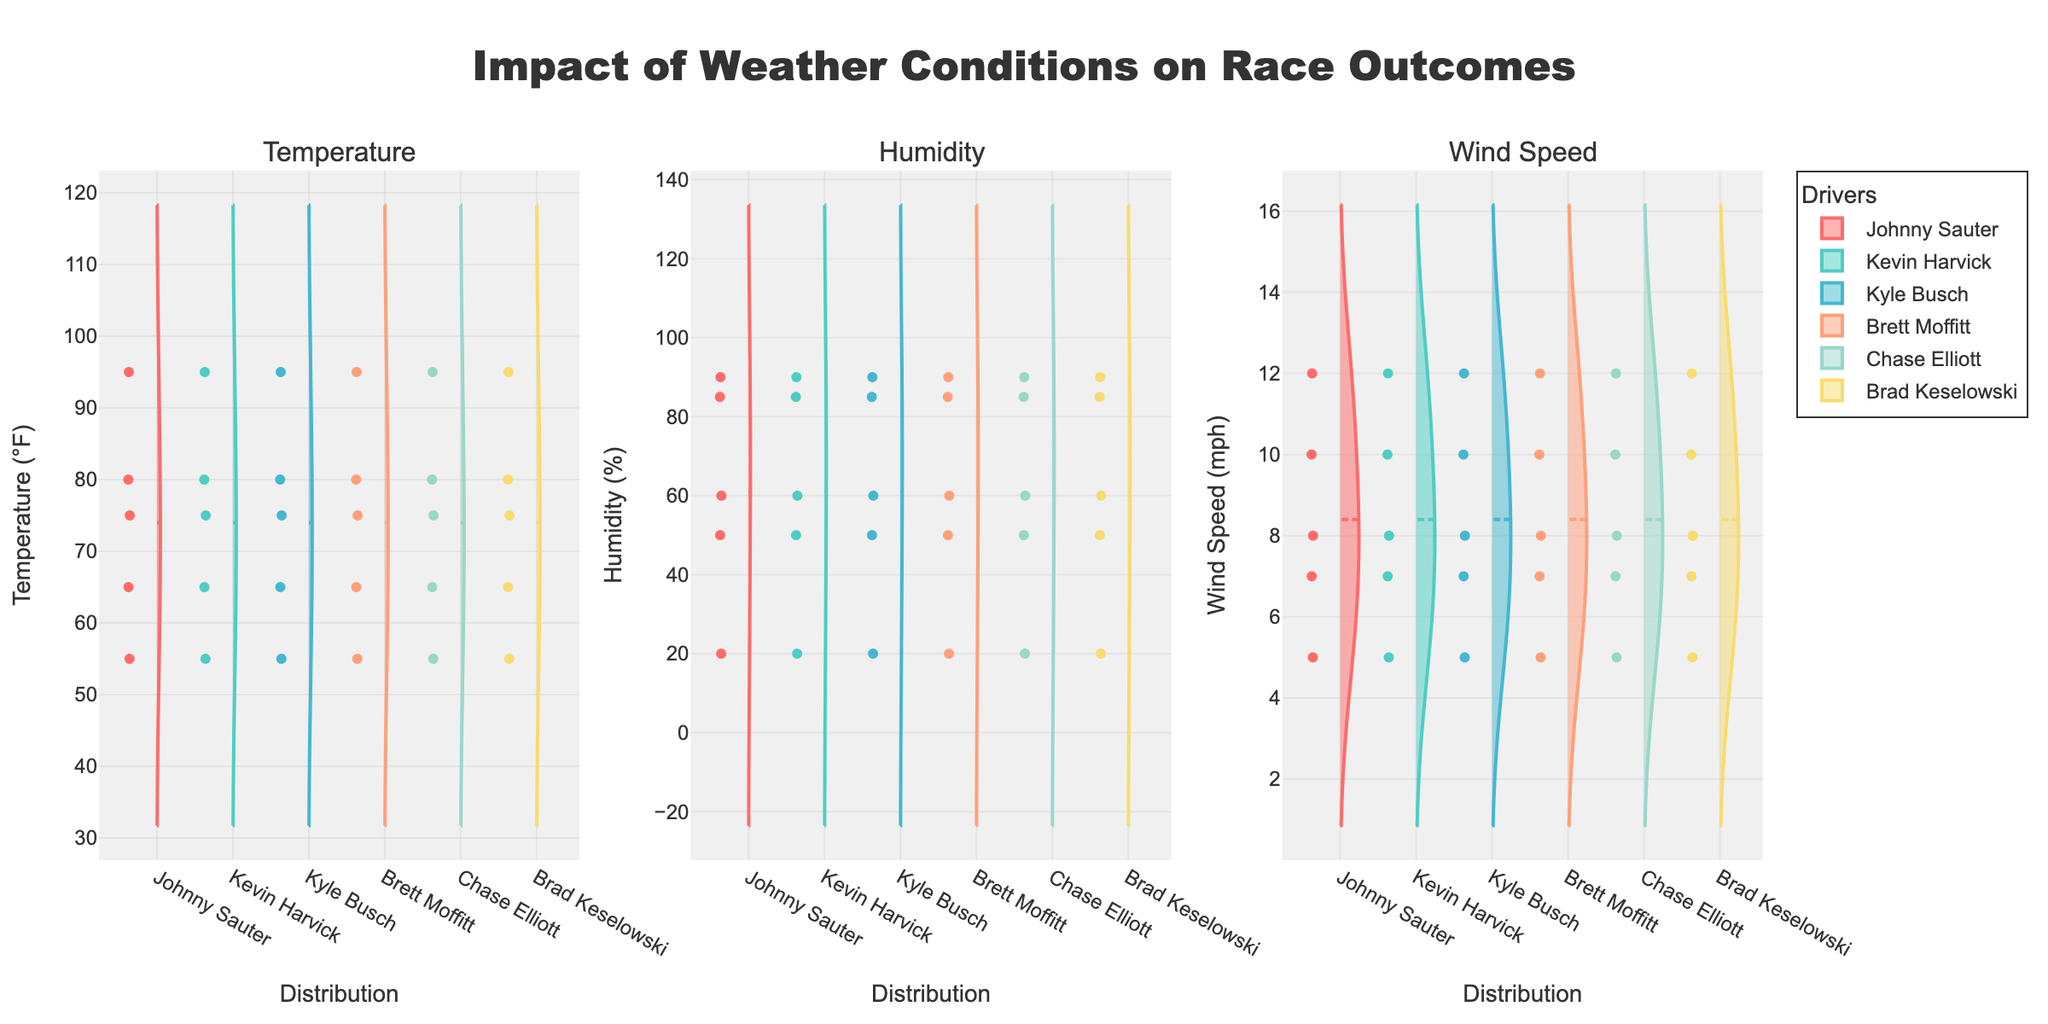How many different weather conditions are represented in the violin plots? There are three subplots, which correspond to Temperature, Humidity, and Wind Speed. Each subplot contains data from different weather conditions.
Answer: Three How is Johnny Sauter's performance in the Temperature subplot visually represented compared to the other drivers? Johnny Sauter's performance in the Temperature subplot can be seen by observing the position of his data points in the first violin plot. His values are shown alongside other drivers for comparison.
Answer: Alongside Which driver has the highest frequency of data points in the Humidity subplot? To determine which driver has the highest frequency of data points in the Humidity subplot, look at the density of the points in the second subplot's violin plot. The driver with the narrowest and tallest spread will have the highest frequency.
Answer: Need visual inspection Is there any driver whose performance seems consistent across all three subplots? Consistency across subplots would be indicated by similar distribution patterns in all three violin plots for a driver. Check each subplot for the driver to see if the general shape and spread are similar.
Answer: Need visual inspection What is the range of values for Wind Speed for Chase Elliott? For Chase Elliott, look at the spread of data points in the Wind Speed subplot. The range is the difference between the highest and lowest points.
Answer: Need visual inspection How does Kevin Harvick’s Temperature distribution compare to that of Brad Keselowski? Compare the shapes and spread of the data points for Kevin Harvick and Brad Keselowski in the Temperature subplot. You should see if they have different ranges, medians, or overall shape patterns.
Answer: Need visual inspection In the Humidity subplot, what is the median humidity value for Johnny Sauter, and how does it compare to the overall median? The median value can be identified by the mean line in the violin plot for Johnny Sauter. Compare this to the overall median shown by the general density of the plot.
Answer: Need visual inspection Which subplot shows the most variation in the displayed data? To find the subplot with the most variation, compare the spread and distribution shapes of all three subplots. The subplot with the widest and most varied data points has the most variation.
Answer: Need visual inspection How do the weather conditions for Phoenix compare in terms of Wind Speed with those for Daytona 500? By examining the density and range of the Wind Speed data points for Phoenix and Daytona 500 night race, compare how tightly clustered or spread out the points are.
Answer: Need visual inspection Which condition appears to have the least impact on the drivers' positions when comparing the violin plots? The least impactful condition would show similar distribution patterns across all drivers, indicating that their positions are unaffected by the condition.
Answer: Need visual inspection 